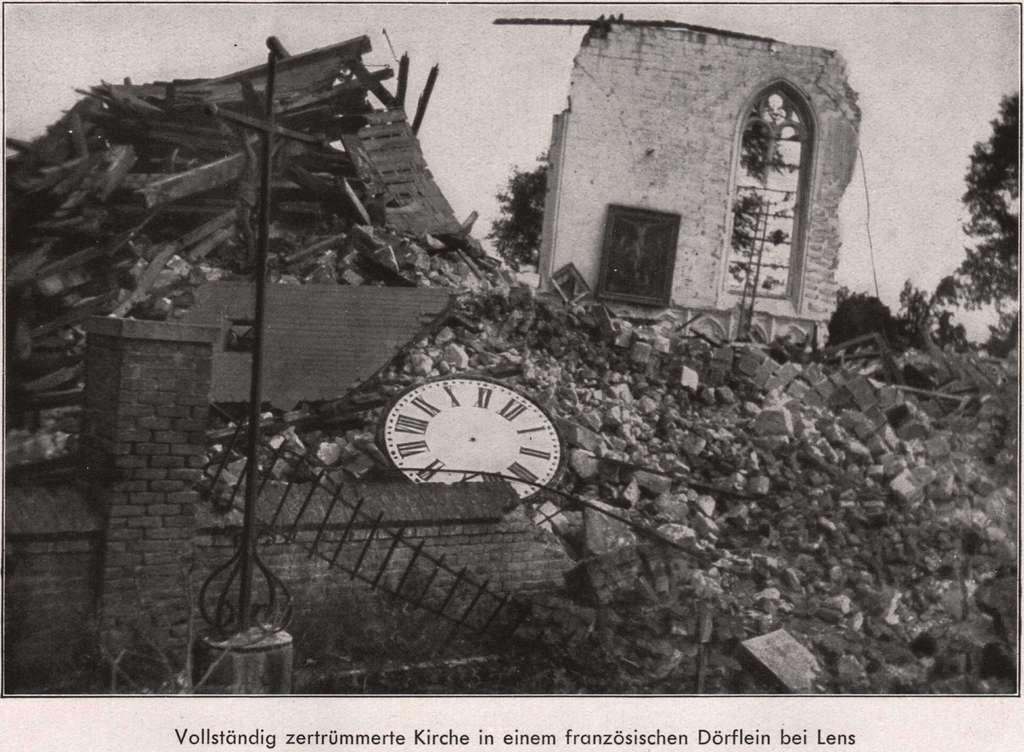<image>
Create a compact narrative representing the image presented. A caption for a picture showing an area of rubble starts, "Vollstandig.". 